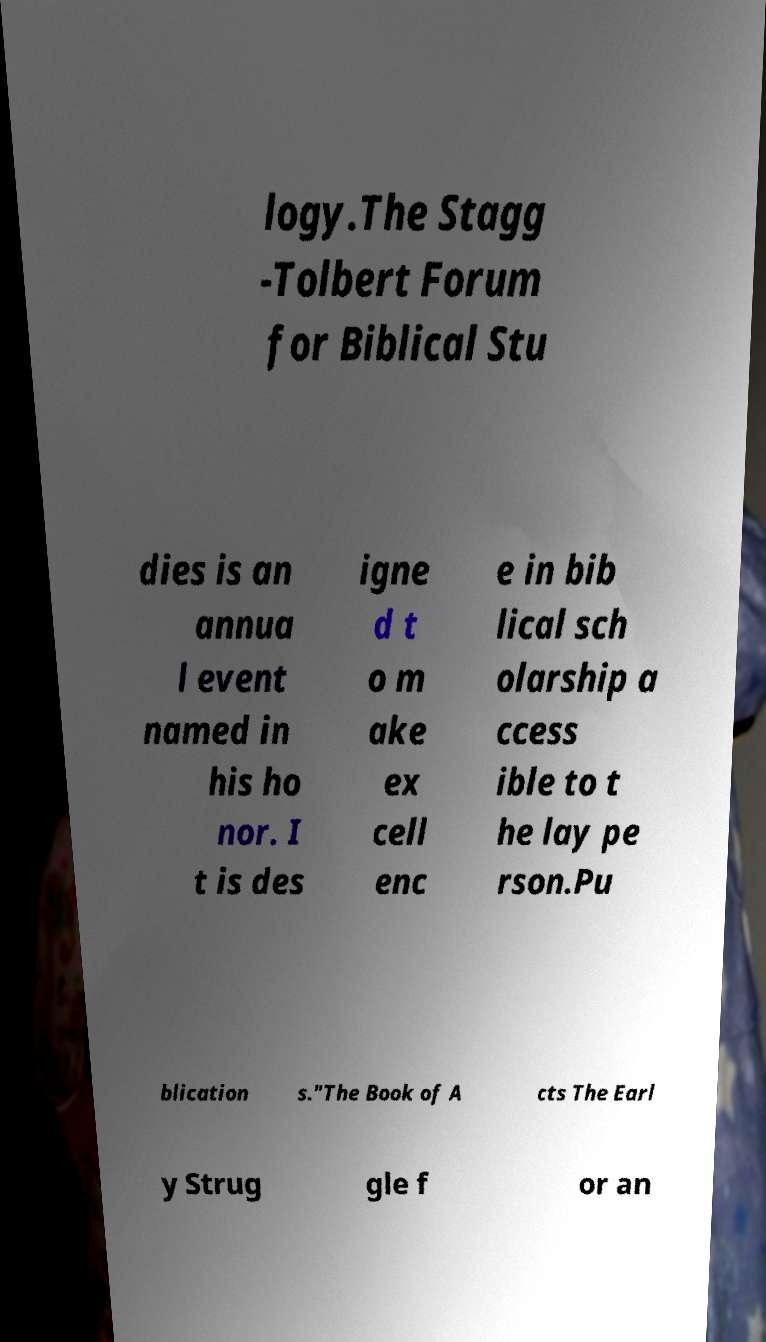Can you accurately transcribe the text from the provided image for me? logy.The Stagg -Tolbert Forum for Biblical Stu dies is an annua l event named in his ho nor. I t is des igne d t o m ake ex cell enc e in bib lical sch olarship a ccess ible to t he lay pe rson.Pu blication s."The Book of A cts The Earl y Strug gle f or an 